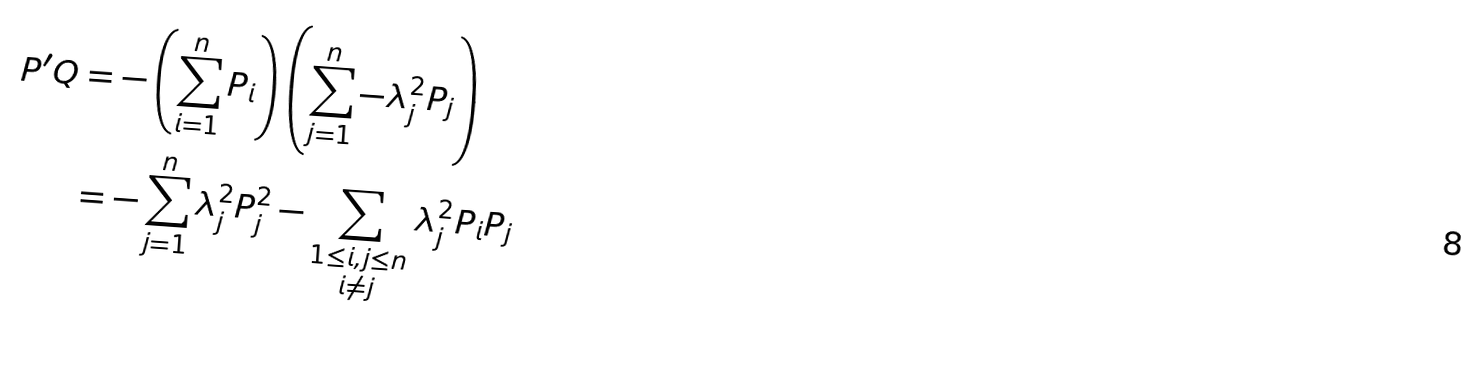<formula> <loc_0><loc_0><loc_500><loc_500>P ^ { \prime } Q & = - \left ( \sum _ { i = 1 } ^ { n } P _ { i } \right ) \left ( \sum _ { j = 1 } ^ { n } - \lambda _ { j } ^ { 2 } P _ { j } \right ) \\ & = - \sum _ { j = 1 } ^ { n } \lambda _ { j } ^ { 2 } P _ { j } ^ { 2 } - \sum _ { \substack { 1 \leq i , j \leq n \\ i \neq j } } \lambda _ { j } ^ { 2 } P _ { i } P _ { j }</formula> 